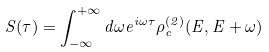<formula> <loc_0><loc_0><loc_500><loc_500>S ( \tau ) = \int _ { - \infty } ^ { + \infty } d \omega e ^ { i \omega \tau } \rho ^ { ( 2 ) } _ { c } ( E , E + { \omega } )</formula> 